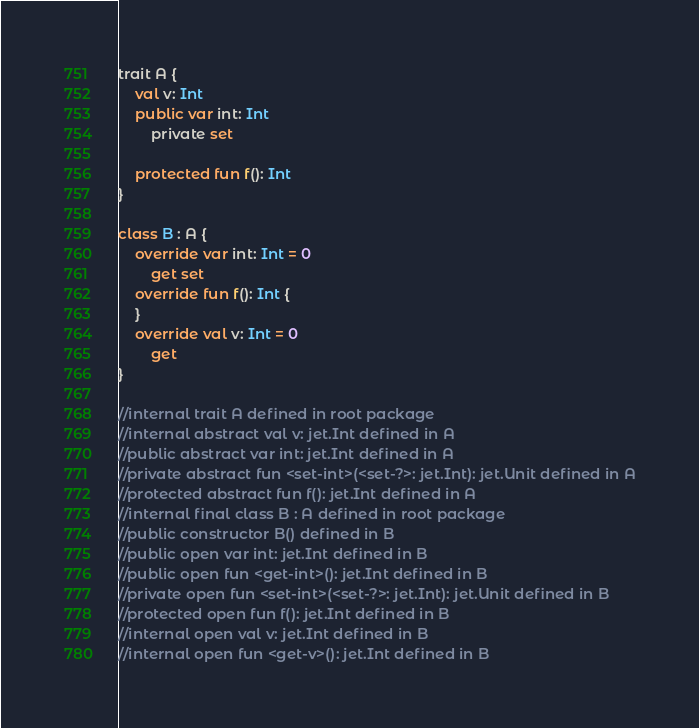Convert code to text. <code><loc_0><loc_0><loc_500><loc_500><_Kotlin_>trait A {
    val v: Int
    public var int: Int
        private set

    protected fun f(): Int
}

class B : A {
    override var int: Int = 0
        get set
    override fun f(): Int {
    }
    override val v: Int = 0
        get
}

//internal trait A defined in root package
//internal abstract val v: jet.Int defined in A
//public abstract var int: jet.Int defined in A
//private abstract fun <set-int>(<set-?>: jet.Int): jet.Unit defined in A
//protected abstract fun f(): jet.Int defined in A
//internal final class B : A defined in root package
//public constructor B() defined in B
//public open var int: jet.Int defined in B
//public open fun <get-int>(): jet.Int defined in B
//private open fun <set-int>(<set-?>: jet.Int): jet.Unit defined in B
//protected open fun f(): jet.Int defined in B
//internal open val v: jet.Int defined in B
//internal open fun <get-v>(): jet.Int defined in B
</code> 